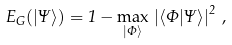Convert formula to latex. <formula><loc_0><loc_0><loc_500><loc_500>E _ { G } ( | \Psi \rangle ) = 1 - \max _ { | \Phi \rangle } \, \left | \langle \Phi | \Psi \rangle \right | ^ { 2 } \, ,</formula> 